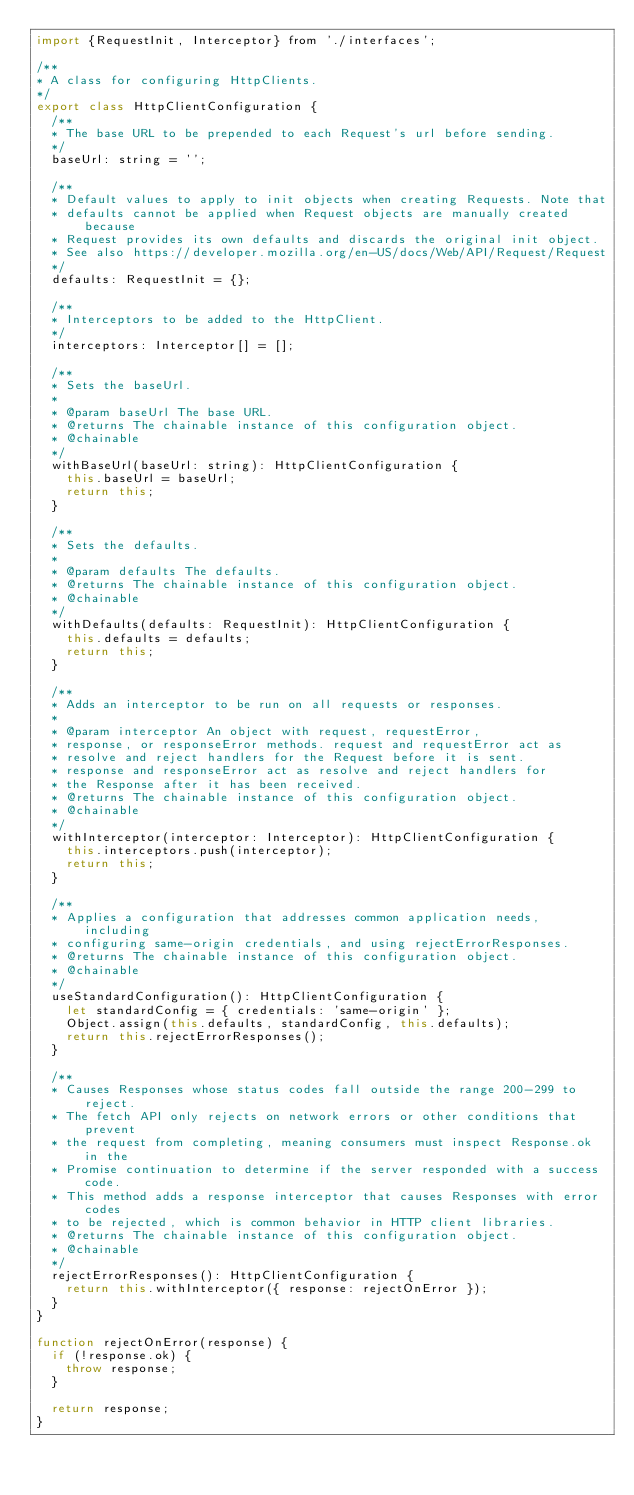<code> <loc_0><loc_0><loc_500><loc_500><_JavaScript_>import {RequestInit, Interceptor} from './interfaces';

/**
* A class for configuring HttpClients.
*/
export class HttpClientConfiguration {
  /**
  * The base URL to be prepended to each Request's url before sending.
  */
  baseUrl: string = '';

  /**
  * Default values to apply to init objects when creating Requests. Note that
  * defaults cannot be applied when Request objects are manually created because
  * Request provides its own defaults and discards the original init object.
  * See also https://developer.mozilla.org/en-US/docs/Web/API/Request/Request
  */
  defaults: RequestInit = {};

  /**
  * Interceptors to be added to the HttpClient.
  */
  interceptors: Interceptor[] = [];

  /**
  * Sets the baseUrl.
  *
  * @param baseUrl The base URL.
  * @returns The chainable instance of this configuration object.
  * @chainable
  */
  withBaseUrl(baseUrl: string): HttpClientConfiguration {
    this.baseUrl = baseUrl;
    return this;
  }

  /**
  * Sets the defaults.
  *
  * @param defaults The defaults.
  * @returns The chainable instance of this configuration object.
  * @chainable
  */
  withDefaults(defaults: RequestInit): HttpClientConfiguration {
    this.defaults = defaults;
    return this;
  }

  /**
  * Adds an interceptor to be run on all requests or responses.
  *
  * @param interceptor An object with request, requestError,
  * response, or responseError methods. request and requestError act as
  * resolve and reject handlers for the Request before it is sent.
  * response and responseError act as resolve and reject handlers for
  * the Response after it has been received.
  * @returns The chainable instance of this configuration object.
  * @chainable
  */
  withInterceptor(interceptor: Interceptor): HttpClientConfiguration {
    this.interceptors.push(interceptor);
    return this;
  }

  /**
  * Applies a configuration that addresses common application needs, including
  * configuring same-origin credentials, and using rejectErrorResponses.
  * @returns The chainable instance of this configuration object.
  * @chainable
  */
  useStandardConfiguration(): HttpClientConfiguration {
    let standardConfig = { credentials: 'same-origin' };
    Object.assign(this.defaults, standardConfig, this.defaults);
    return this.rejectErrorResponses();
  }

  /**
  * Causes Responses whose status codes fall outside the range 200-299 to reject.
  * The fetch API only rejects on network errors or other conditions that prevent
  * the request from completing, meaning consumers must inspect Response.ok in the
  * Promise continuation to determine if the server responded with a success code.
  * This method adds a response interceptor that causes Responses with error codes
  * to be rejected, which is common behavior in HTTP client libraries.
  * @returns The chainable instance of this configuration object.
  * @chainable
  */
  rejectErrorResponses(): HttpClientConfiguration {
    return this.withInterceptor({ response: rejectOnError });
  }
}

function rejectOnError(response) {
  if (!response.ok) {
    throw response;
  }

  return response;
}
</code> 